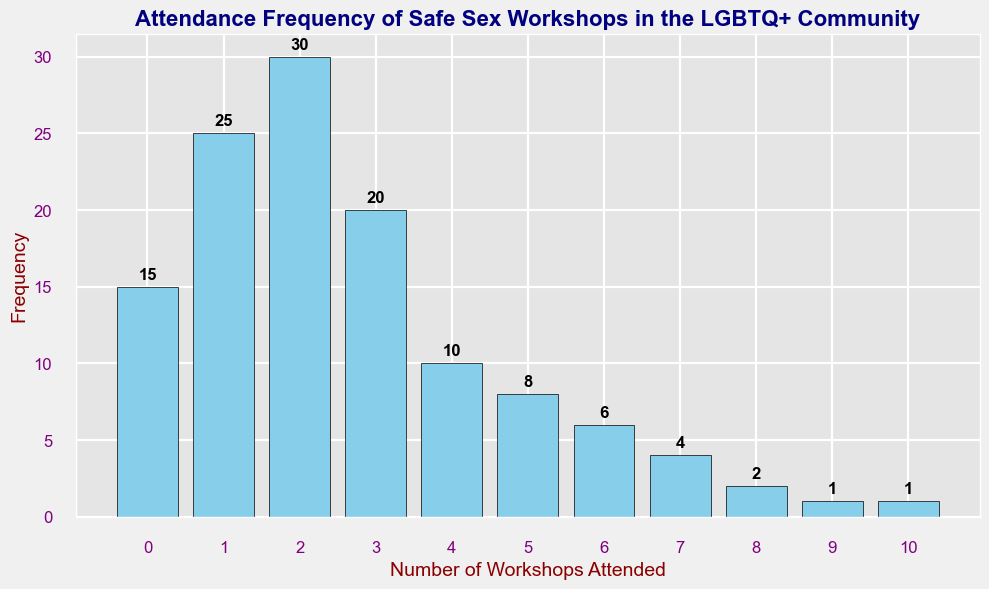How many people attended between 4 and 8 workshops? Count the frequencies for the number of workshops between 4 and 8: 10 + 8 + 6 + 4 + 2 = 30
Answer: 30 Which number of workshops had the highest attendance frequency? Identify the bar with the highest height; it corresponds to 2 workshops with a frequency of 30
Answer: 2 What is the total number of people who attended at least one workshop? Sum the frequencies for the number of workshops from 1 to 10: 25 + 30 + 20 + 10 + 8 + 6 + 4 + 2 + 1 + 1 = 107
Answer: 107 Are there more people who attended exactly 1 workshop or exactly 3 workshops? Compare the heights of the bars for 1 and 3 workshops; 1 workshop has a frequency of 25 and 3 workshops has a frequency of 20
Answer: 1 workshop What is the least attended number of workshops? Identify the bar with the lowest non-zero height; it corresponds to 9 and 10 workshops with a frequency of 1 each
Answer: 9 and 10 How does the frequency of attending 0 workshops compare to the frequency of attending 5 workshops? Compare the heights of the bars for 0 and 5 workshops; 0 workshops has a frequency of 15 while 5 workshops has a frequency of 8
Answer: 0 is greater Which frequency is indicated by the tallest bar? Identify the bar that reaches the highest point on the y-axis; the tallest bar is at 2 workshops with a frequency of 30
Answer: 30 What is the combined frequency of people who attended either 0 or exactly 1 workshop? Sum the frequencies for 0 and 1 workshops: 15 + 25 = 40
Answer: 40 How many more people attended exactly 2 workshops compared to those who attended exactly 4 workshops? Subtract the frequency of 4 workshops from the frequency of 2 workshops: 30 - 10 = 20
Answer: 20 What is the median number of workshops attended by the community members? Arrange the frequencies in an ordered list and find the middle value(s). Discuss and adjust if necessary. (Explanation is lengthy due to steps involving counting middle frequencies in cumulative order)
Answer: 2 